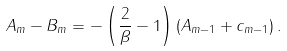Convert formula to latex. <formula><loc_0><loc_0><loc_500><loc_500>A _ { m } - B _ { m } = - \left ( \frac { 2 } { \beta } - 1 \right ) ( A _ { m - 1 } + c _ { m - 1 } ) \, .</formula> 